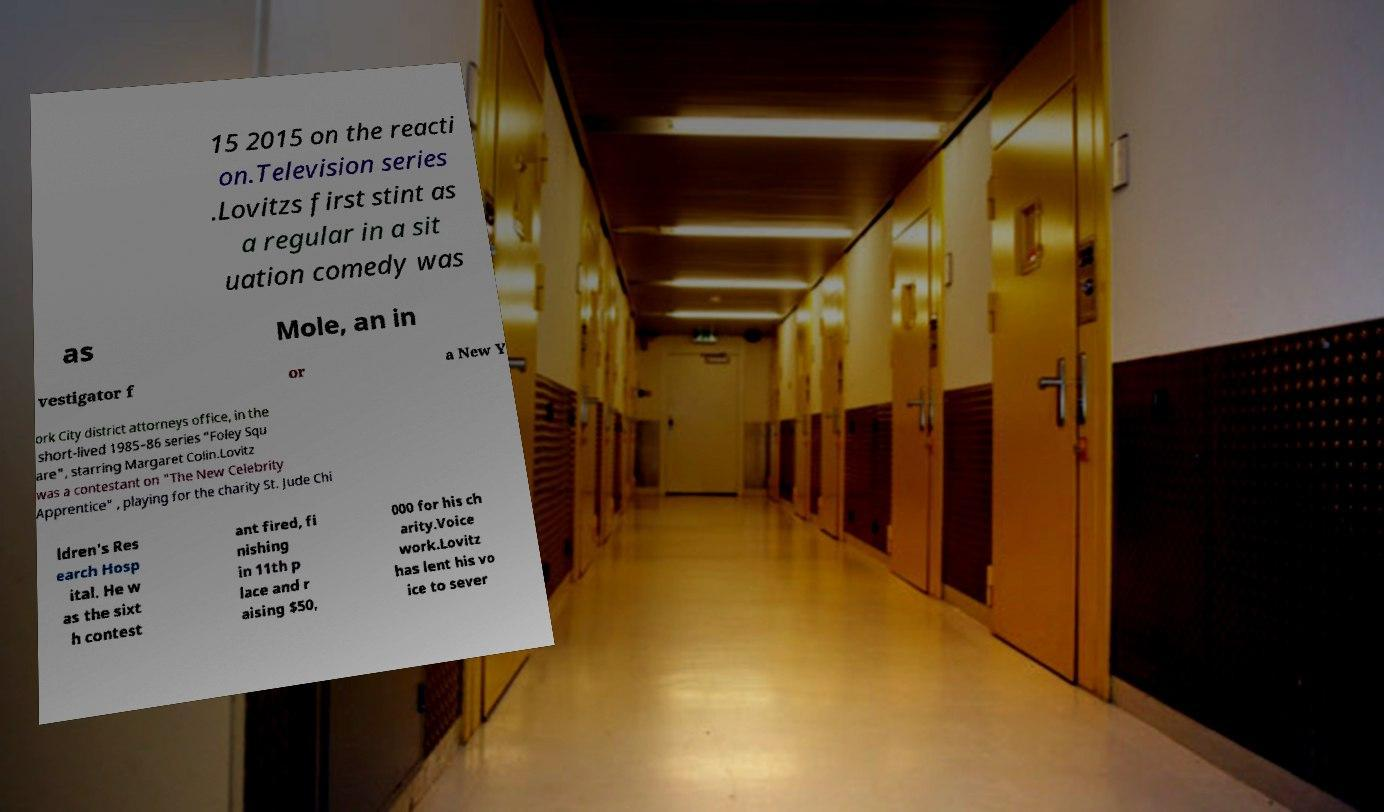Could you extract and type out the text from this image? 15 2015 on the reacti on.Television series .Lovitzs first stint as a regular in a sit uation comedy was as Mole, an in vestigator f or a New Y ork City district attorneys office, in the short-lived 1985–86 series "Foley Squ are", starring Margaret Colin.Lovitz was a contestant on "The New Celebrity Apprentice" , playing for the charity St. Jude Chi ldren's Res earch Hosp ital. He w as the sixt h contest ant fired, fi nishing in 11th p lace and r aising $50, 000 for his ch arity.Voice work.Lovitz has lent his vo ice to sever 